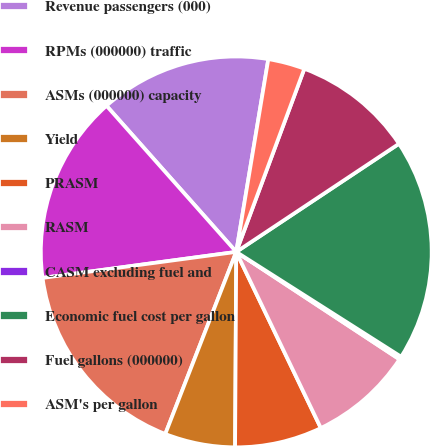Convert chart. <chart><loc_0><loc_0><loc_500><loc_500><pie_chart><fcel>Revenue passengers (000)<fcel>RPMs (000000) traffic<fcel>ASMs (000000) capacity<fcel>Yield<fcel>PRASM<fcel>RASM<fcel>CASM excluding fuel and<fcel>Economic fuel cost per gallon<fcel>Fuel gallons (000000)<fcel>ASM's per gallon<nl><fcel>14.18%<fcel>15.57%<fcel>16.96%<fcel>5.82%<fcel>7.22%<fcel>8.61%<fcel>0.25%<fcel>18.35%<fcel>10.0%<fcel>3.04%<nl></chart> 